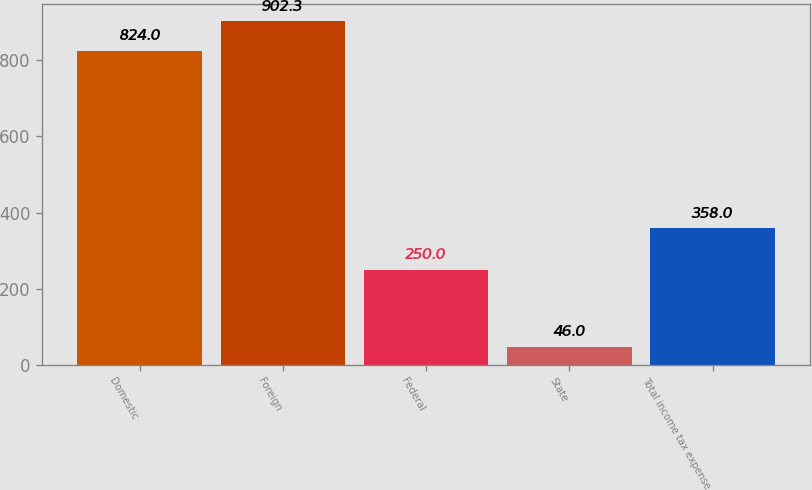Convert chart. <chart><loc_0><loc_0><loc_500><loc_500><bar_chart><fcel>Domestic<fcel>Foreign<fcel>Federal<fcel>State<fcel>Total income tax expense<nl><fcel>824<fcel>902.3<fcel>250<fcel>46<fcel>358<nl></chart> 